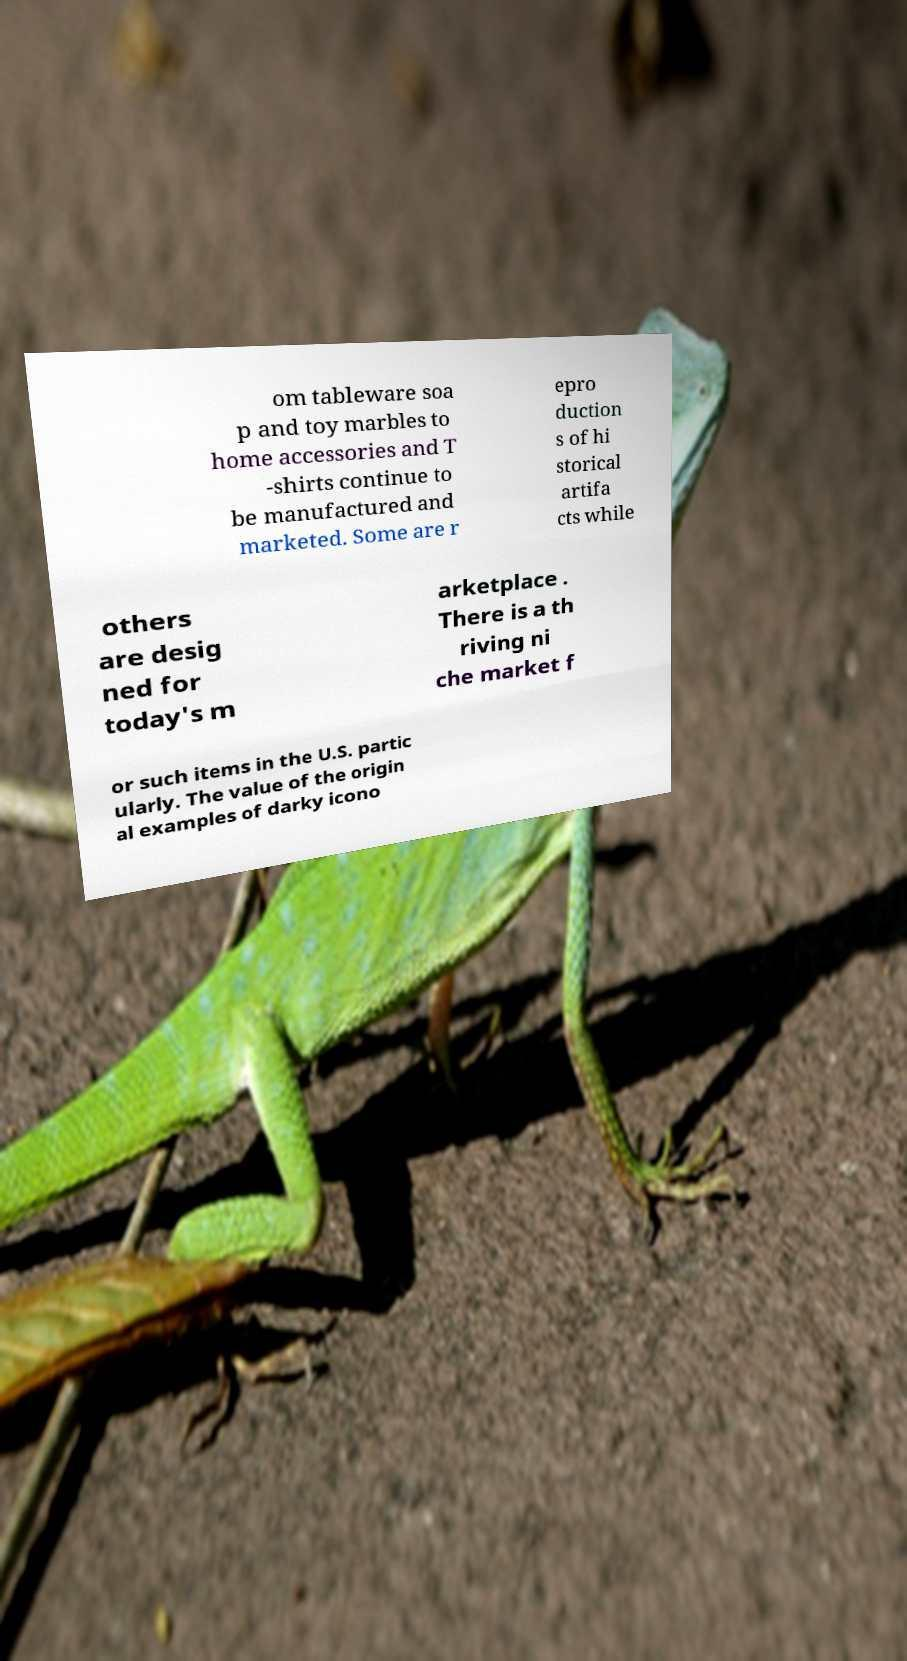What messages or text are displayed in this image? I need them in a readable, typed format. om tableware soa p and toy marbles to home accessories and T -shirts continue to be manufactured and marketed. Some are r epro duction s of hi storical artifa cts while others are desig ned for today's m arketplace . There is a th riving ni che market f or such items in the U.S. partic ularly. The value of the origin al examples of darky icono 